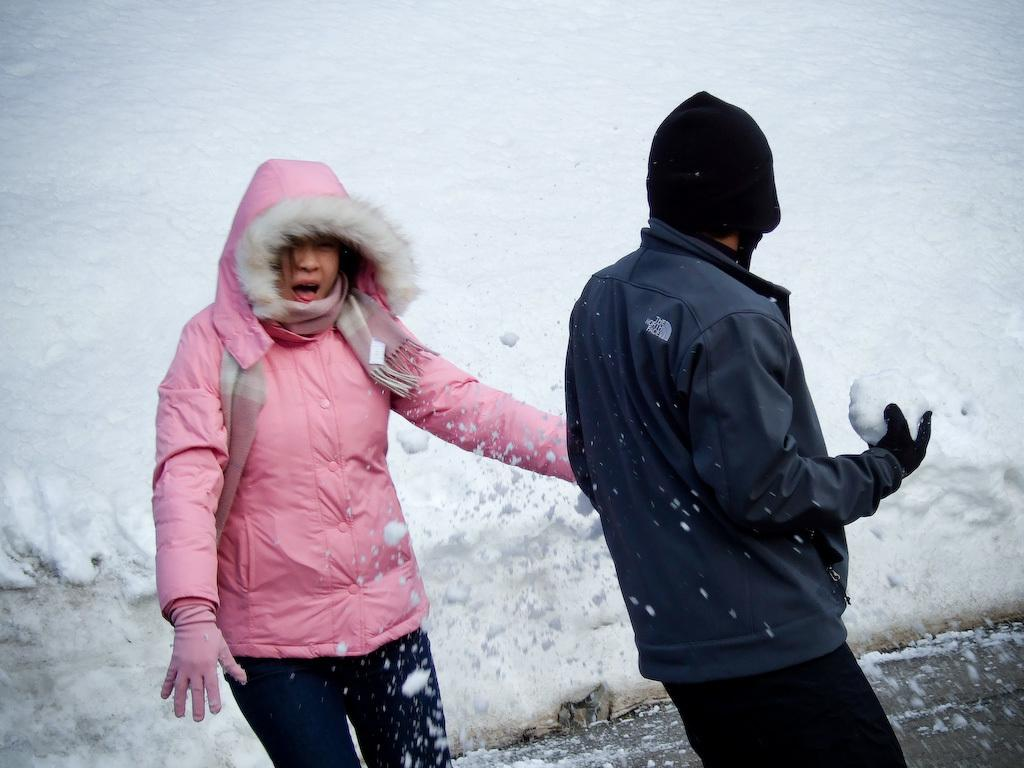Who are the people in the image? There is a man and a lady in the image. What are the man and lady doing in the image? The man and lady are standing. What can be seen in the background of the image? There is sky visible in the background of the image. What type of mountain is visible in the background of the image? There is no mountain visible in the background of the image; only the sky is present. What is the facial expression of the lady in the image? The provided facts do not mention the facial expressions of the man and lady, so it cannot be determined from the image. 